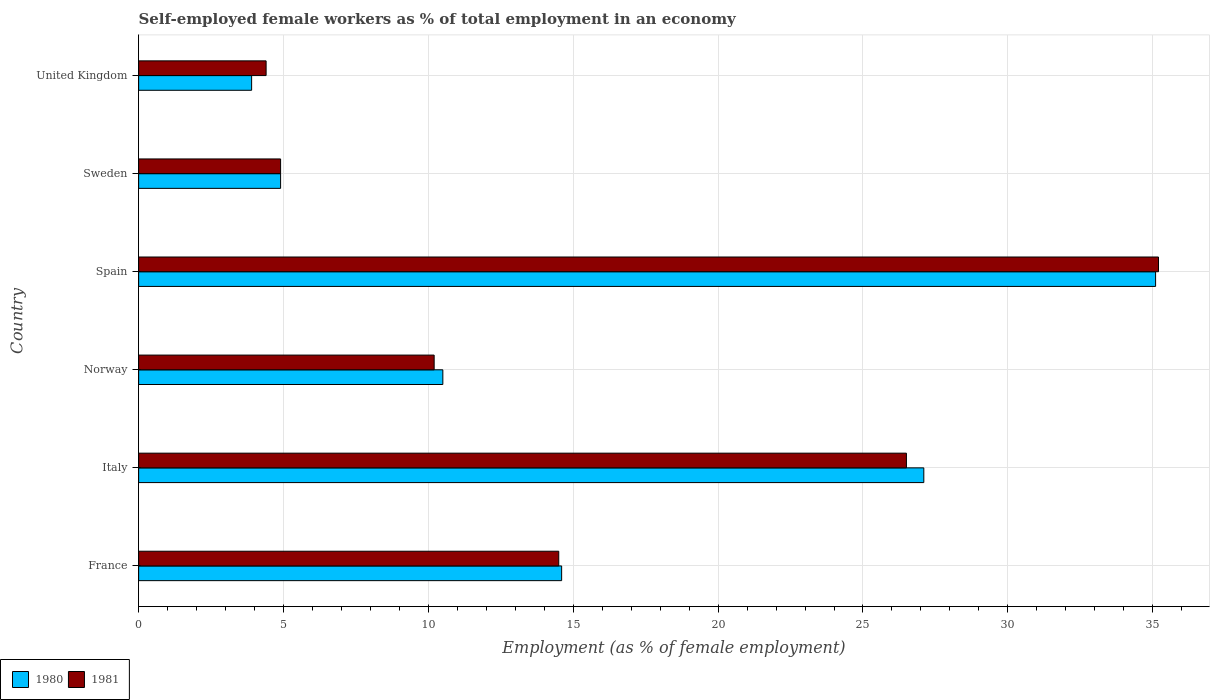How many different coloured bars are there?
Provide a short and direct response. 2. Are the number of bars per tick equal to the number of legend labels?
Provide a succinct answer. Yes. How many bars are there on the 5th tick from the top?
Ensure brevity in your answer.  2. How many bars are there on the 4th tick from the bottom?
Provide a succinct answer. 2. What is the percentage of self-employed female workers in 1980 in Norway?
Provide a short and direct response. 10.5. Across all countries, what is the maximum percentage of self-employed female workers in 1980?
Make the answer very short. 35.1. Across all countries, what is the minimum percentage of self-employed female workers in 1980?
Ensure brevity in your answer.  3.9. In which country was the percentage of self-employed female workers in 1980 maximum?
Your answer should be compact. Spain. In which country was the percentage of self-employed female workers in 1980 minimum?
Keep it short and to the point. United Kingdom. What is the total percentage of self-employed female workers in 1981 in the graph?
Provide a short and direct response. 95.7. What is the difference between the percentage of self-employed female workers in 1980 in Spain and the percentage of self-employed female workers in 1981 in Sweden?
Make the answer very short. 30.2. What is the average percentage of self-employed female workers in 1981 per country?
Give a very brief answer. 15.95. What is the difference between the percentage of self-employed female workers in 1980 and percentage of self-employed female workers in 1981 in Italy?
Offer a very short reply. 0.6. What is the ratio of the percentage of self-employed female workers in 1980 in France to that in Norway?
Provide a succinct answer. 1.39. Is the percentage of self-employed female workers in 1980 in France less than that in United Kingdom?
Offer a terse response. No. What is the difference between the highest and the second highest percentage of self-employed female workers in 1980?
Give a very brief answer. 8. What is the difference between the highest and the lowest percentage of self-employed female workers in 1980?
Give a very brief answer. 31.2. In how many countries, is the percentage of self-employed female workers in 1981 greater than the average percentage of self-employed female workers in 1981 taken over all countries?
Your response must be concise. 2. Are all the bars in the graph horizontal?
Your response must be concise. Yes. Are the values on the major ticks of X-axis written in scientific E-notation?
Provide a short and direct response. No. Does the graph contain grids?
Offer a very short reply. Yes. What is the title of the graph?
Provide a short and direct response. Self-employed female workers as % of total employment in an economy. Does "1964" appear as one of the legend labels in the graph?
Ensure brevity in your answer.  No. What is the label or title of the X-axis?
Give a very brief answer. Employment (as % of female employment). What is the label or title of the Y-axis?
Offer a very short reply. Country. What is the Employment (as % of female employment) of 1980 in France?
Offer a terse response. 14.6. What is the Employment (as % of female employment) of 1981 in France?
Provide a short and direct response. 14.5. What is the Employment (as % of female employment) in 1980 in Italy?
Your answer should be very brief. 27.1. What is the Employment (as % of female employment) in 1980 in Norway?
Your answer should be compact. 10.5. What is the Employment (as % of female employment) in 1981 in Norway?
Provide a succinct answer. 10.2. What is the Employment (as % of female employment) of 1980 in Spain?
Your response must be concise. 35.1. What is the Employment (as % of female employment) of 1981 in Spain?
Provide a short and direct response. 35.2. What is the Employment (as % of female employment) in 1980 in Sweden?
Your response must be concise. 4.9. What is the Employment (as % of female employment) in 1981 in Sweden?
Keep it short and to the point. 4.9. What is the Employment (as % of female employment) in 1980 in United Kingdom?
Your answer should be very brief. 3.9. What is the Employment (as % of female employment) of 1981 in United Kingdom?
Your answer should be very brief. 4.4. Across all countries, what is the maximum Employment (as % of female employment) in 1980?
Keep it short and to the point. 35.1. Across all countries, what is the maximum Employment (as % of female employment) of 1981?
Your answer should be compact. 35.2. Across all countries, what is the minimum Employment (as % of female employment) of 1980?
Ensure brevity in your answer.  3.9. Across all countries, what is the minimum Employment (as % of female employment) of 1981?
Your answer should be very brief. 4.4. What is the total Employment (as % of female employment) in 1980 in the graph?
Your answer should be compact. 96.1. What is the total Employment (as % of female employment) in 1981 in the graph?
Give a very brief answer. 95.7. What is the difference between the Employment (as % of female employment) in 1980 in France and that in Italy?
Make the answer very short. -12.5. What is the difference between the Employment (as % of female employment) of 1981 in France and that in Italy?
Give a very brief answer. -12. What is the difference between the Employment (as % of female employment) in 1980 in France and that in Spain?
Keep it short and to the point. -20.5. What is the difference between the Employment (as % of female employment) of 1981 in France and that in Spain?
Keep it short and to the point. -20.7. What is the difference between the Employment (as % of female employment) in 1981 in France and that in Sweden?
Provide a short and direct response. 9.6. What is the difference between the Employment (as % of female employment) of 1980 in Italy and that in Spain?
Offer a terse response. -8. What is the difference between the Employment (as % of female employment) of 1981 in Italy and that in Spain?
Your response must be concise. -8.7. What is the difference between the Employment (as % of female employment) of 1980 in Italy and that in Sweden?
Keep it short and to the point. 22.2. What is the difference between the Employment (as % of female employment) in 1981 in Italy and that in Sweden?
Provide a short and direct response. 21.6. What is the difference between the Employment (as % of female employment) of 1980 in Italy and that in United Kingdom?
Give a very brief answer. 23.2. What is the difference between the Employment (as % of female employment) of 1981 in Italy and that in United Kingdom?
Make the answer very short. 22.1. What is the difference between the Employment (as % of female employment) of 1980 in Norway and that in Spain?
Offer a very short reply. -24.6. What is the difference between the Employment (as % of female employment) of 1980 in Norway and that in Sweden?
Offer a terse response. 5.6. What is the difference between the Employment (as % of female employment) in 1981 in Norway and that in United Kingdom?
Keep it short and to the point. 5.8. What is the difference between the Employment (as % of female employment) in 1980 in Spain and that in Sweden?
Make the answer very short. 30.2. What is the difference between the Employment (as % of female employment) of 1981 in Spain and that in Sweden?
Offer a very short reply. 30.3. What is the difference between the Employment (as % of female employment) of 1980 in Spain and that in United Kingdom?
Provide a succinct answer. 31.2. What is the difference between the Employment (as % of female employment) of 1981 in Spain and that in United Kingdom?
Provide a short and direct response. 30.8. What is the difference between the Employment (as % of female employment) in 1980 in Sweden and that in United Kingdom?
Provide a short and direct response. 1. What is the difference between the Employment (as % of female employment) of 1981 in Sweden and that in United Kingdom?
Provide a succinct answer. 0.5. What is the difference between the Employment (as % of female employment) in 1980 in France and the Employment (as % of female employment) in 1981 in Italy?
Keep it short and to the point. -11.9. What is the difference between the Employment (as % of female employment) of 1980 in France and the Employment (as % of female employment) of 1981 in Norway?
Make the answer very short. 4.4. What is the difference between the Employment (as % of female employment) in 1980 in France and the Employment (as % of female employment) in 1981 in Spain?
Make the answer very short. -20.6. What is the difference between the Employment (as % of female employment) of 1980 in Italy and the Employment (as % of female employment) of 1981 in United Kingdom?
Offer a terse response. 22.7. What is the difference between the Employment (as % of female employment) of 1980 in Norway and the Employment (as % of female employment) of 1981 in Spain?
Ensure brevity in your answer.  -24.7. What is the difference between the Employment (as % of female employment) of 1980 in Norway and the Employment (as % of female employment) of 1981 in Sweden?
Make the answer very short. 5.6. What is the difference between the Employment (as % of female employment) of 1980 in Norway and the Employment (as % of female employment) of 1981 in United Kingdom?
Your answer should be very brief. 6.1. What is the difference between the Employment (as % of female employment) in 1980 in Spain and the Employment (as % of female employment) in 1981 in Sweden?
Your answer should be very brief. 30.2. What is the difference between the Employment (as % of female employment) of 1980 in Spain and the Employment (as % of female employment) of 1981 in United Kingdom?
Provide a short and direct response. 30.7. What is the average Employment (as % of female employment) of 1980 per country?
Offer a very short reply. 16.02. What is the average Employment (as % of female employment) of 1981 per country?
Keep it short and to the point. 15.95. What is the difference between the Employment (as % of female employment) of 1980 and Employment (as % of female employment) of 1981 in Spain?
Ensure brevity in your answer.  -0.1. What is the ratio of the Employment (as % of female employment) in 1980 in France to that in Italy?
Ensure brevity in your answer.  0.54. What is the ratio of the Employment (as % of female employment) of 1981 in France to that in Italy?
Offer a very short reply. 0.55. What is the ratio of the Employment (as % of female employment) in 1980 in France to that in Norway?
Give a very brief answer. 1.39. What is the ratio of the Employment (as % of female employment) of 1981 in France to that in Norway?
Your response must be concise. 1.42. What is the ratio of the Employment (as % of female employment) in 1980 in France to that in Spain?
Offer a very short reply. 0.42. What is the ratio of the Employment (as % of female employment) in 1981 in France to that in Spain?
Your answer should be very brief. 0.41. What is the ratio of the Employment (as % of female employment) of 1980 in France to that in Sweden?
Give a very brief answer. 2.98. What is the ratio of the Employment (as % of female employment) of 1981 in France to that in Sweden?
Provide a succinct answer. 2.96. What is the ratio of the Employment (as % of female employment) of 1980 in France to that in United Kingdom?
Provide a short and direct response. 3.74. What is the ratio of the Employment (as % of female employment) in 1981 in France to that in United Kingdom?
Offer a terse response. 3.3. What is the ratio of the Employment (as % of female employment) in 1980 in Italy to that in Norway?
Your answer should be very brief. 2.58. What is the ratio of the Employment (as % of female employment) of 1981 in Italy to that in Norway?
Ensure brevity in your answer.  2.6. What is the ratio of the Employment (as % of female employment) in 1980 in Italy to that in Spain?
Make the answer very short. 0.77. What is the ratio of the Employment (as % of female employment) in 1981 in Italy to that in Spain?
Your answer should be compact. 0.75. What is the ratio of the Employment (as % of female employment) in 1980 in Italy to that in Sweden?
Offer a very short reply. 5.53. What is the ratio of the Employment (as % of female employment) in 1981 in Italy to that in Sweden?
Provide a succinct answer. 5.41. What is the ratio of the Employment (as % of female employment) in 1980 in Italy to that in United Kingdom?
Your answer should be very brief. 6.95. What is the ratio of the Employment (as % of female employment) in 1981 in Italy to that in United Kingdom?
Your answer should be compact. 6.02. What is the ratio of the Employment (as % of female employment) of 1980 in Norway to that in Spain?
Offer a very short reply. 0.3. What is the ratio of the Employment (as % of female employment) of 1981 in Norway to that in Spain?
Keep it short and to the point. 0.29. What is the ratio of the Employment (as % of female employment) in 1980 in Norway to that in Sweden?
Give a very brief answer. 2.14. What is the ratio of the Employment (as % of female employment) of 1981 in Norway to that in Sweden?
Offer a very short reply. 2.08. What is the ratio of the Employment (as % of female employment) in 1980 in Norway to that in United Kingdom?
Give a very brief answer. 2.69. What is the ratio of the Employment (as % of female employment) of 1981 in Norway to that in United Kingdom?
Ensure brevity in your answer.  2.32. What is the ratio of the Employment (as % of female employment) in 1980 in Spain to that in Sweden?
Offer a very short reply. 7.16. What is the ratio of the Employment (as % of female employment) of 1981 in Spain to that in Sweden?
Ensure brevity in your answer.  7.18. What is the ratio of the Employment (as % of female employment) of 1980 in Spain to that in United Kingdom?
Keep it short and to the point. 9. What is the ratio of the Employment (as % of female employment) of 1981 in Spain to that in United Kingdom?
Your answer should be compact. 8. What is the ratio of the Employment (as % of female employment) of 1980 in Sweden to that in United Kingdom?
Keep it short and to the point. 1.26. What is the ratio of the Employment (as % of female employment) of 1981 in Sweden to that in United Kingdom?
Ensure brevity in your answer.  1.11. What is the difference between the highest and the lowest Employment (as % of female employment) of 1980?
Keep it short and to the point. 31.2. What is the difference between the highest and the lowest Employment (as % of female employment) of 1981?
Keep it short and to the point. 30.8. 